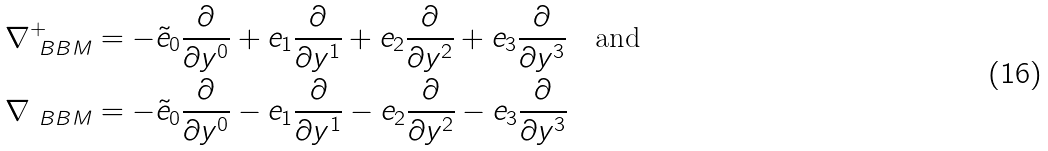Convert formula to latex. <formula><loc_0><loc_0><loc_500><loc_500>\nabla ^ { + } _ { \ B B M } & = - \tilde { e } _ { 0 } \frac { \partial } { \partial y ^ { 0 } } + e _ { 1 } \frac { \partial } { \partial y ^ { 1 } } + e _ { 2 } \frac { \partial } { \partial y ^ { 2 } } + e _ { 3 } \frac { \partial } { \partial y ^ { 3 } } \quad \text {and} \\ \nabla _ { \ B B M } & = - \tilde { e } _ { 0 } \frac { \partial } { \partial y ^ { 0 } } - e _ { 1 } \frac { \partial } { \partial y ^ { 1 } } - e _ { 2 } \frac { \partial } { \partial y ^ { 2 } } - e _ { 3 } \frac { \partial } { \partial y ^ { 3 } }</formula> 